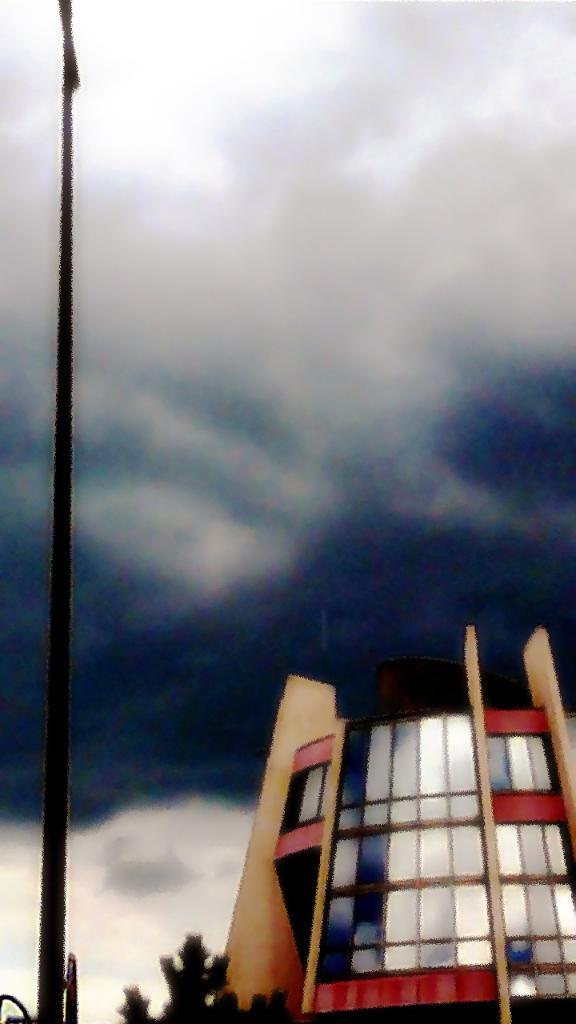What structure is located on the right side of the image? There is a building on the right side of the image. What can be seen on the left side of the image? There is a pole on the left side of the image. What type of vegetation is at the bottom of the image? There is a tree at the bottom of the image. What is visible at the top of the image? The sky is visible at the top of the image. What type of crime is being committed in the image? There is no indication of any crime being committed in the image. What organization is responsible for the pole on the left side of the image? The image does not provide information about the organization responsible for the pole. 